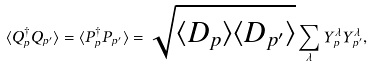<formula> <loc_0><loc_0><loc_500><loc_500>\langle Q _ { p } ^ { \dagger } Q _ { p ^ { \prime } } \rangle = \langle P _ { p } ^ { \dagger } P _ { p ^ { \prime } } \rangle = \sqrt { \langle D _ { p } \rangle \langle D _ { p ^ { \prime } } \rangle } \sum _ { \lambda } Y _ { p } ^ { \lambda } Y _ { p ^ { \prime } } ^ { \lambda } ,</formula> 